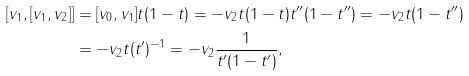Convert formula to latex. <formula><loc_0><loc_0><loc_500><loc_500>[ v _ { 1 } , [ v _ { 1 } , v _ { 2 } ] ] & = [ v _ { 0 } , v _ { 1 } ] t ( 1 - t ) = - v _ { 2 } t ( 1 - t ) t ^ { \prime \prime } ( 1 - t ^ { \prime \prime } ) = - v _ { 2 } t ( 1 - t ^ { \prime \prime } ) \\ & = - v _ { 2 } t ( t ^ { \prime } ) ^ { - 1 } = - v _ { 2 } \frac { 1 } { t ^ { \prime } ( 1 - t ^ { \prime } ) } ,</formula> 